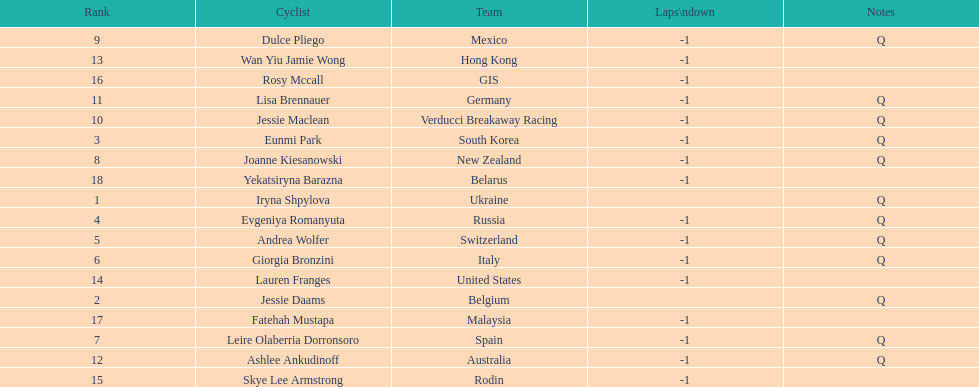Who was the top ranked competitor in this race? Iryna Shpylova. 